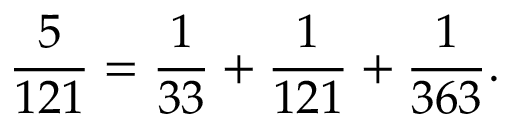Convert formula to latex. <formula><loc_0><loc_0><loc_500><loc_500>{ \frac { 5 } { 1 2 1 } } = { \frac { 1 } { 3 3 } } + { \frac { 1 } { 1 2 1 } } + { \frac { 1 } { 3 6 3 } } .</formula> 